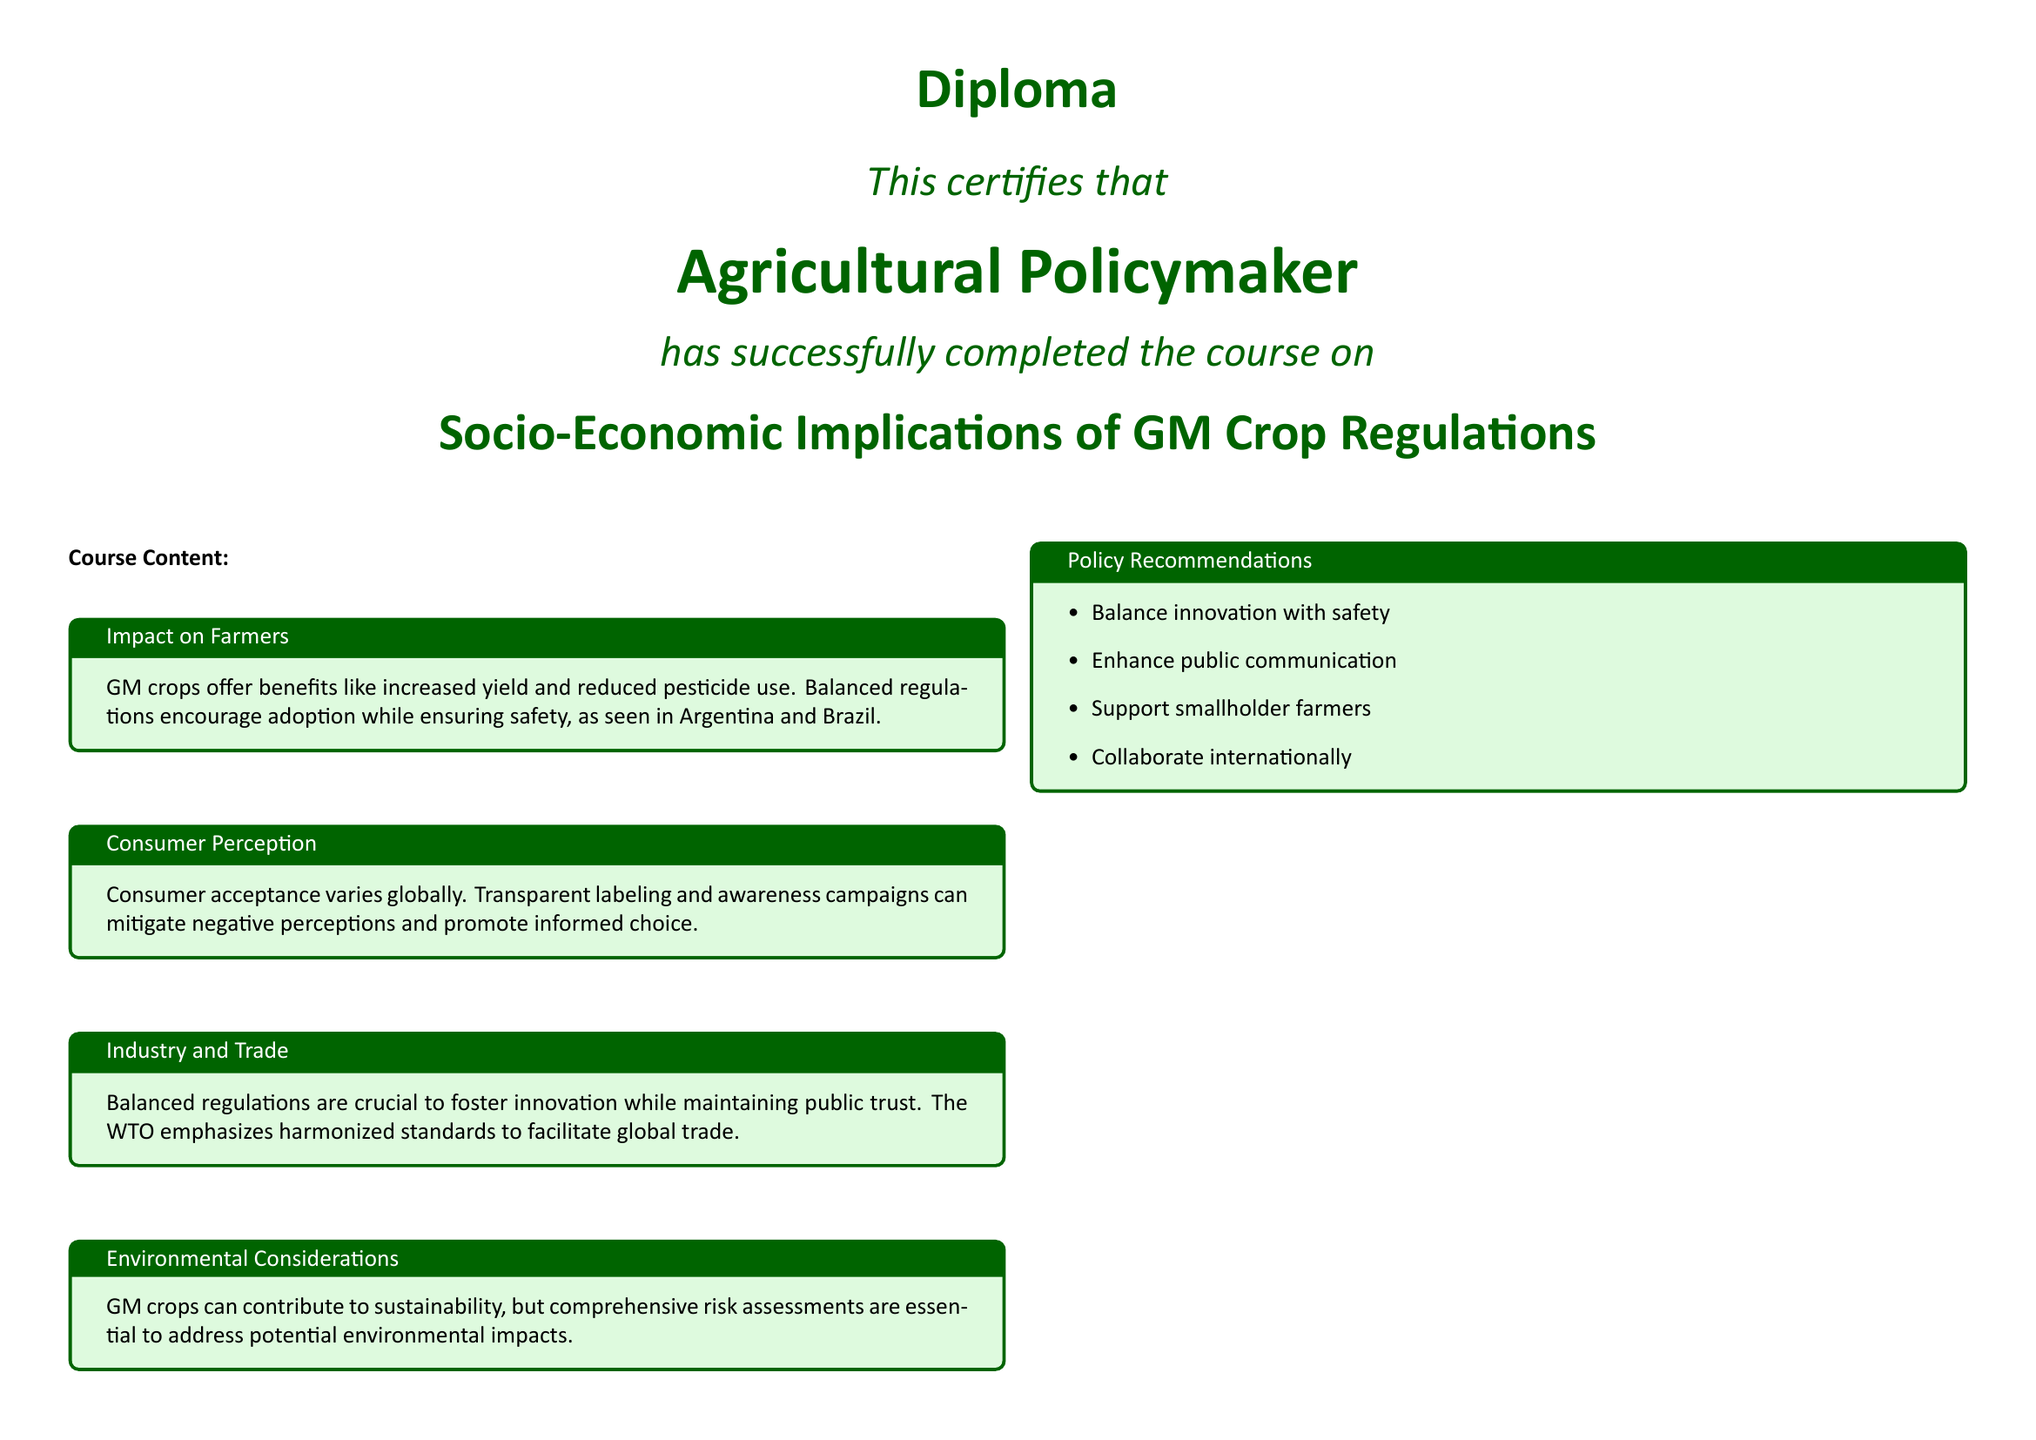What is the title of the diploma? The title of the diploma is found at the top of the document, stating the subject of the course taken.
Answer: Socio-Economic Implications of GM Crop Regulations Who is the recipient of the diploma? The recipient is identified at the center of the document, emphasizing their role.
Answer: Agricultural Policymaker What are the policy recommendations listed? The policy recommendations are items that focus on balancing innovation with safety and supporting farmers, which are detailed in the document.
Answer: Balance innovation with safety, Enhance public communication, Support smallholder farmers, Collaborate internationally Which countries are mentioned as examples of GM crop regulation? The document provides specific examples of countries that have successfully implemented GM crop regulations.
Answer: Argentina and Brazil What is one environmental consideration mentioned? The environmental considerations address sustainability and risks associated with GM crops, as described in the course content.
Answer: Comprehensive risk assessments What does the WT O emphasize regarding trade? The document highlights the importance of trade regulations within an international context, particularly concerning GM crops.
Answer: Harmonized standards What is the color theme used in the diploma? The document features a specific color scheme that contributes to its visual appeal, heavily based on specific green shades.
Answer: Dark green and light green What does the diploma recognize? The final statement of the diploma clarifies the expertise being acknowledged through this certification.
Answer: Expertise in assessing and developing balanced regulatory frameworks for genetically modified crops 